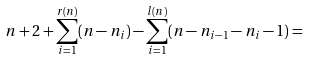<formula> <loc_0><loc_0><loc_500><loc_500>n + 2 + \sum _ { i = 1 } ^ { r ( n ) } ( n - n _ { i } ) - \sum _ { i = 1 } ^ { l ( n ) } ( n - n _ { i - 1 } - n _ { i } - 1 ) =</formula> 